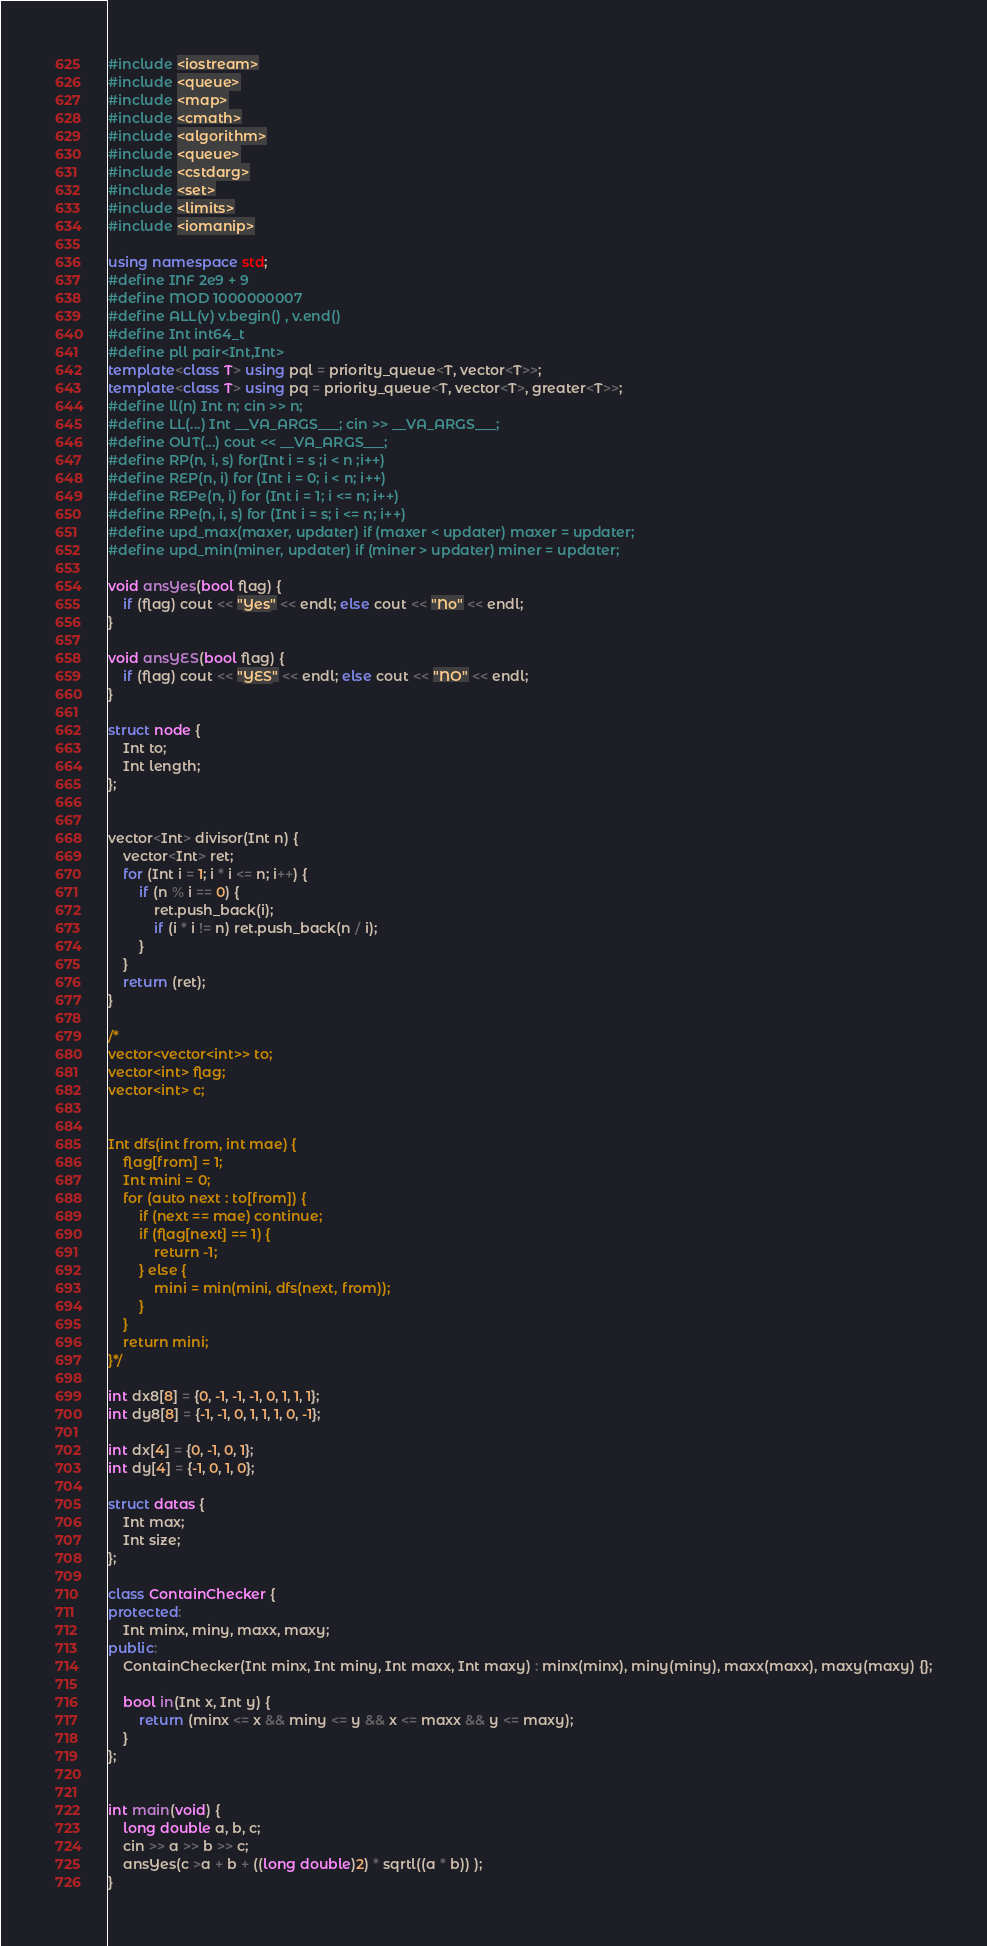<code> <loc_0><loc_0><loc_500><loc_500><_C++_>#include <iostream>
#include <queue>
#include <map>
#include <cmath>
#include <algorithm>
#include <queue>
#include <cstdarg>
#include <set>
#include <limits>
#include <iomanip>

using namespace std;
#define INF 2e9 + 9
#define MOD 1000000007
#define ALL(v) v.begin() , v.end()
#define Int int64_t
#define pll pair<Int,Int>
template<class T> using pql = priority_queue<T, vector<T>>;
template<class T> using pq = priority_queue<T, vector<T>, greater<T>>;
#define ll(n) Int n; cin >> n;
#define LL(...) Int __VA_ARGS___; cin >> __VA_ARGS___;
#define OUT(...) cout << __VA_ARGS___;
#define RP(n, i, s) for(Int i = s ;i < n ;i++)
#define REP(n, i) for (Int i = 0; i < n; i++)
#define REPe(n, i) for (Int i = 1; i <= n; i++)
#define RPe(n, i, s) for (Int i = s; i <= n; i++)
#define upd_max(maxer, updater) if (maxer < updater) maxer = updater;
#define upd_min(miner, updater) if (miner > updater) miner = updater;

void ansYes(bool flag) {
    if (flag) cout << "Yes" << endl; else cout << "No" << endl;
}

void ansYES(bool flag) {
    if (flag) cout << "YES" << endl; else cout << "NO" << endl;
}

struct node {
    Int to;
    Int length;
};


vector<Int> divisor(Int n) {
    vector<Int> ret;
    for (Int i = 1; i * i <= n; i++) {
        if (n % i == 0) {
            ret.push_back(i);
            if (i * i != n) ret.push_back(n / i);
        }
    }
    return (ret);
}

/*
vector<vector<int>> to;
vector<int> flag;
vector<int> c;


Int dfs(int from, int mae) {
    flag[from] = 1;
    Int mini = 0;
    for (auto next : to[from]) {
        if (next == mae) continue;
        if (flag[next] == 1) {
            return -1;
        } else {
            mini = min(mini, dfs(next, from));
        }
    }
    return mini;
}*/

int dx8[8] = {0, -1, -1, -1, 0, 1, 1, 1};
int dy8[8] = {-1, -1, 0, 1, 1, 1, 0, -1};

int dx[4] = {0, -1, 0, 1};
int dy[4] = {-1, 0, 1, 0};

struct datas {
    Int max;
    Int size;
};

class ContainChecker {
protected:
    Int minx, miny, maxx, maxy;
public:
    ContainChecker(Int minx, Int miny, Int maxx, Int maxy) : minx(minx), miny(miny), maxx(maxx), maxy(maxy) {};

    bool in(Int x, Int y) {
        return (minx <= x && miny <= y && x <= maxx && y <= maxy);
    }
};


int main(void) {
    long double a, b, c;
    cin >> a >> b >> c;
    ansYes(c >a + b + ((long double)2) * sqrtl((a * b)) );
}


</code> 